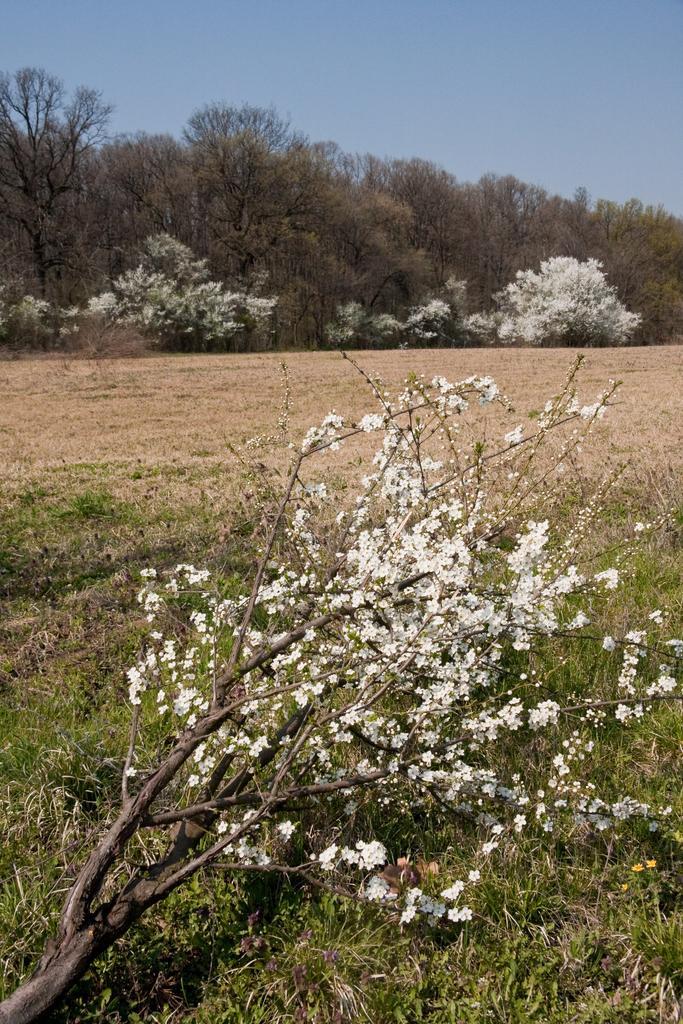Please provide a concise description of this image. In this image we can see the flowers with branch. And we can see the grass. And we can see the land. And we can see the trees. And at the top we can see the sky. 